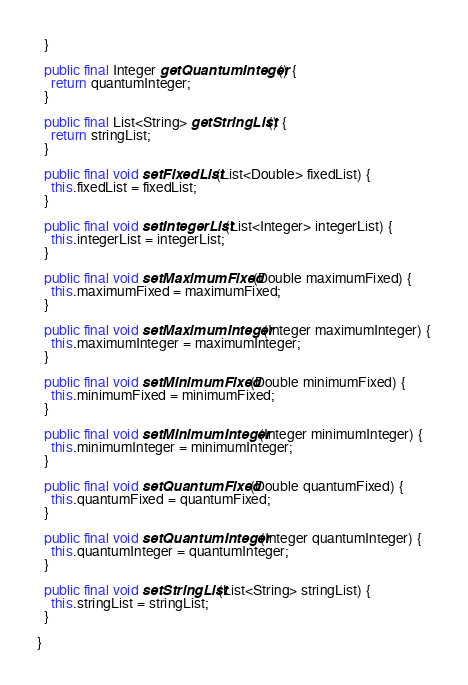Convert code to text. <code><loc_0><loc_0><loc_500><loc_500><_Java_>  }

  public final Integer getQuantumInteger() {
    return quantumInteger;
  }

  public final List<String> getStringList() {
    return stringList;
  }

  public final void setFixedList(List<Double> fixedList) {
    this.fixedList = fixedList;
  }

  public final void setIntegerList(List<Integer> integerList) {
    this.integerList = integerList;
  }

  public final void setMaximumFixed(Double maximumFixed) {
    this.maximumFixed = maximumFixed;
  }

  public final void setMaximumInteger(Integer maximumInteger) {
    this.maximumInteger = maximumInteger;
  }

  public final void setMinimumFixed(Double minimumFixed) {
    this.minimumFixed = minimumFixed;
  }

  public final void setMinimumInteger(Integer minimumInteger) {
    this.minimumInteger = minimumInteger;
  }

  public final void setQuantumFixed(Double quantumFixed) {
    this.quantumFixed = quantumFixed;
  }

  public final void setQuantumInteger(Integer quantumInteger) {
    this.quantumInteger = quantumInteger;
  }

  public final void setStringList(List<String> stringList) {
    this.stringList = stringList;
  }

}
</code> 